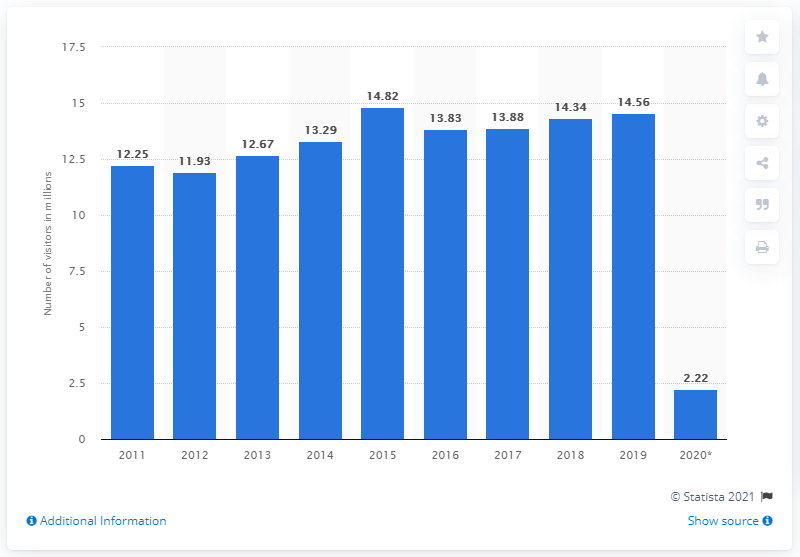Identify some key points in this picture. In 2020, approximately 2.22 million visitors from Western Europe traveled to the United States. In 2019, the number of visitors from Western Europe to the United States was 14.56... 